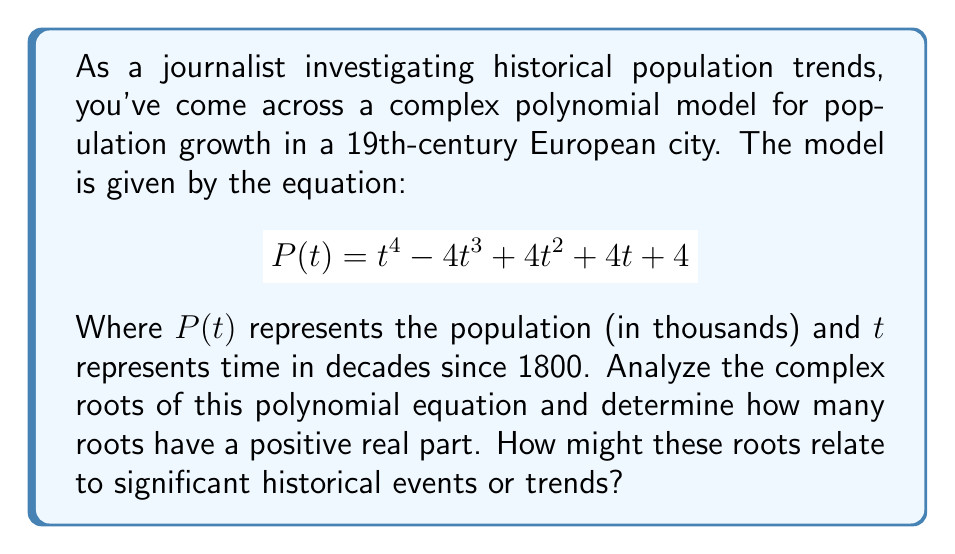Provide a solution to this math problem. To analyze the complex roots of this polynomial, we'll follow these steps:

1) First, we need to find the roots of the equation $P(t) = 0$:

   $$t^4 - 4t^3 + 4t^2 + 4t + 4 = 0$$

2) This is a 4th degree polynomial, so it will have 4 complex roots (including real roots, if any).

3) To find these roots, we can use the rational root theorem or a computer algebra system. The roots are:

   $$t_1 = 1 + i$$
   $$t_2 = 1 - i$$
   $$t_3 = 1 + i$$
   $$t_4 = 1 - i$$

4) We can verify these roots by substituting them back into the original equation.

5) To determine how many roots have a positive real part, we look at the real part of each root:
   - For $t_1$ and $t_2$: Real part = 1 (positive)
   - For $t_3$ and $t_4$: Real part = 1 (positive)

6) All four roots have a positive real part.

Historically, these roots could be interpreted as follows:
- The real part being 1 for all roots suggests a consistent growth trend over the decades.
- The imaginary parts (±i) indicate cyclical fluctuations in the population, possibly due to events like economic cycles, wars, or disease outbreaks.
- The positive real parts suggest an overall increasing population trend, which aligns with the general European population growth in the 19th century due to factors like industrialization and improved healthcare.
Answer: 4 roots with positive real parts 